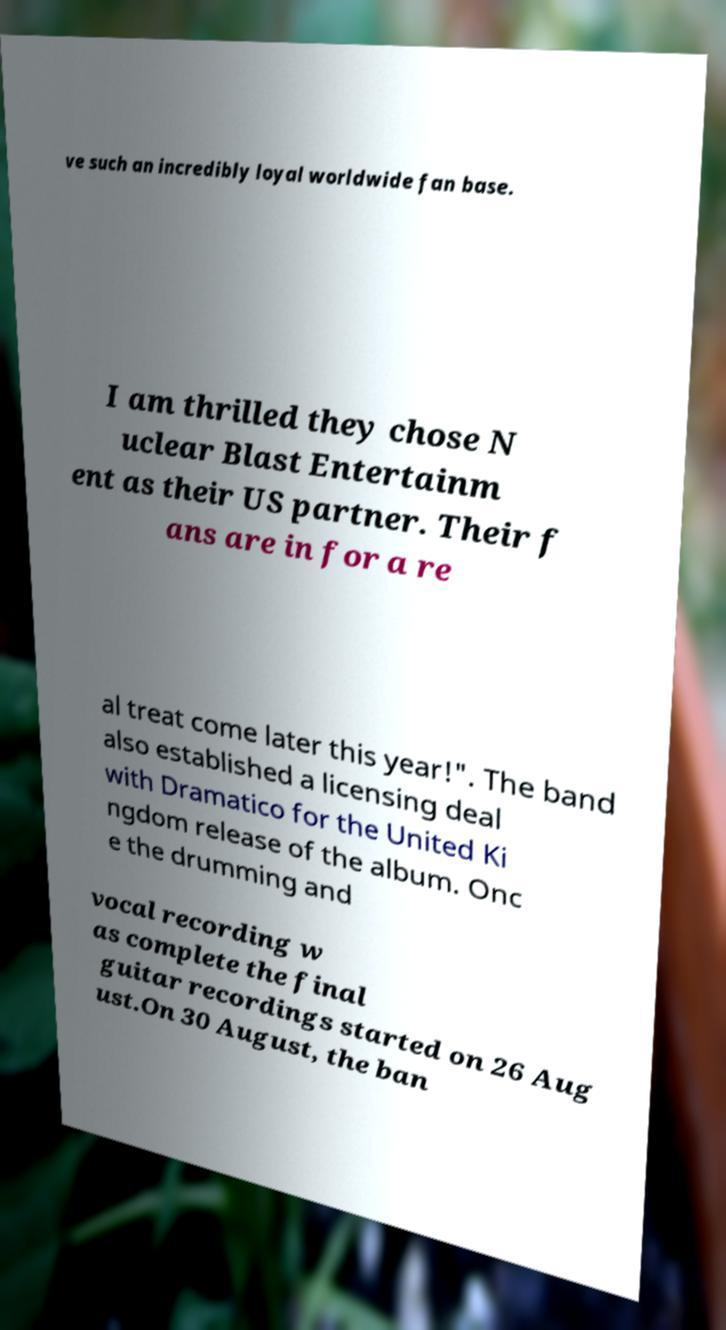I need the written content from this picture converted into text. Can you do that? ve such an incredibly loyal worldwide fan base. I am thrilled they chose N uclear Blast Entertainm ent as their US partner. Their f ans are in for a re al treat come later this year!". The band also established a licensing deal with Dramatico for the United Ki ngdom release of the album. Onc e the drumming and vocal recording w as complete the final guitar recordings started on 26 Aug ust.On 30 August, the ban 